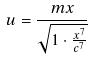<formula> <loc_0><loc_0><loc_500><loc_500>u = \frac { m x } { \sqrt { 1 \cdot \frac { x ^ { 7 } } { c ^ { 7 } } } }</formula> 